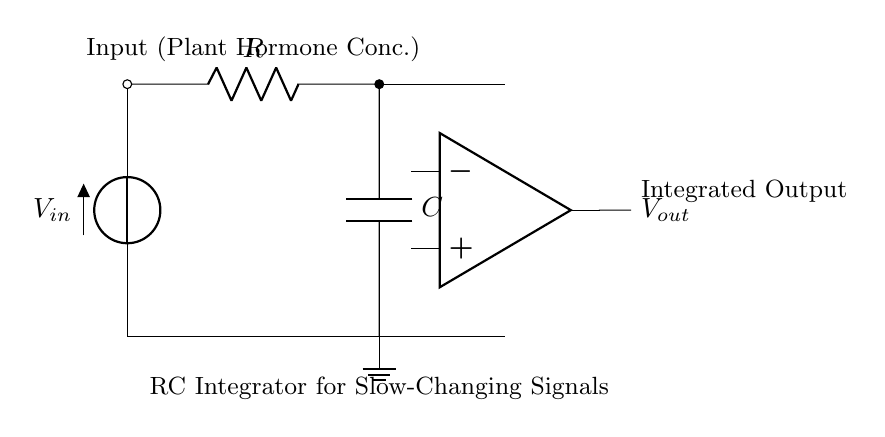What type of circuit is this? This circuit is an RC integrator circuit since it contains a resistor and a capacitor connected in such a way that it performs integration of the input signal.
Answer: RC integrator What is the role of the capacitor in this circuit? The capacitor stores charge and thus integrates the input voltage over time, smoothing out fast changes and allowing for the measurement of slow changes in hormone concentrations.
Answer: Integration What is the output signal? The output (Vout) is the integrated voltage representing the cumulative effect of the input voltage (plant hormone concentration) over time.
Answer: Integrated Output What is the input to this circuit? The input to the circuit is the concentration of plant hormones, which is represented as Vin in the diagram.
Answer: Plant Hormone Conc How does the resistor affect the circuit's operation? The resistor influences the time constant of the circuit, which determines how quickly the capacitor charges and discharges, affecting the response time of the integration.
Answer: Time constant What will happen if the resistance is increased? Increasing the resistance will increase the time constant, causing the circuit to respond more slowly to changes in the input signal, thus integrating values over a longer period.
Answer: Slower response What components are connected in series in this circuit? In this circuit, the resistor and the capacitor are connected in series with the input voltage source leading to the operational amplifier.
Answer: Resistor and Capacitor 